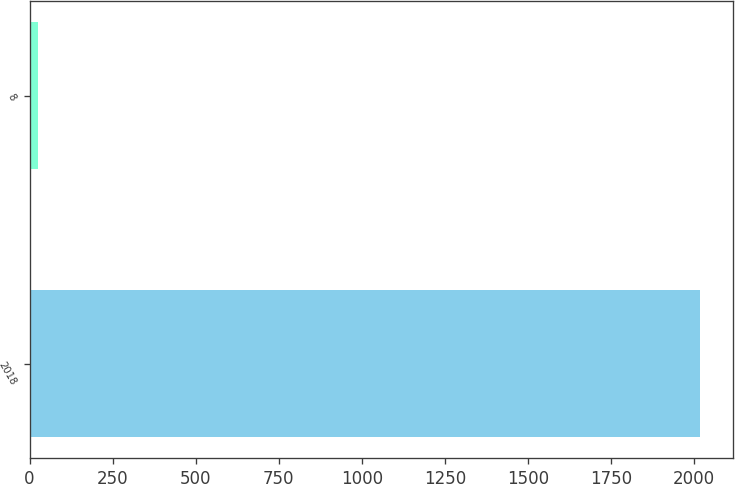<chart> <loc_0><loc_0><loc_500><loc_500><bar_chart><fcel>2018<fcel>8<nl><fcel>2017<fcel>26<nl></chart> 